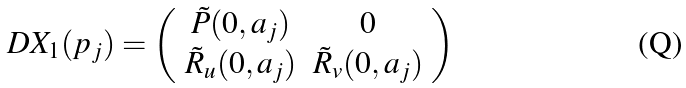<formula> <loc_0><loc_0><loc_500><loc_500>D X _ { 1 } ( p _ { j } ) = \left ( \begin{array} { c c } \tilde { P } ( 0 , a _ { j } ) & 0 \\ \tilde { R } _ { u } ( 0 , a _ { j } ) & \tilde { R } _ { v } ( 0 , a _ { j } ) \\ \end{array} \right )</formula> 